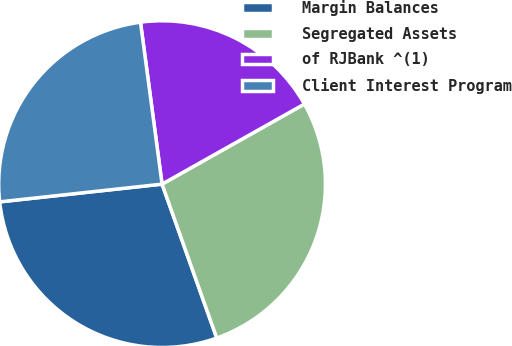Convert chart. <chart><loc_0><loc_0><loc_500><loc_500><pie_chart><fcel>Margin Balances<fcel>Segregated Assets<fcel>of RJBank ^(1)<fcel>Client Interest Program<nl><fcel>28.7%<fcel>27.72%<fcel>18.95%<fcel>24.62%<nl></chart> 